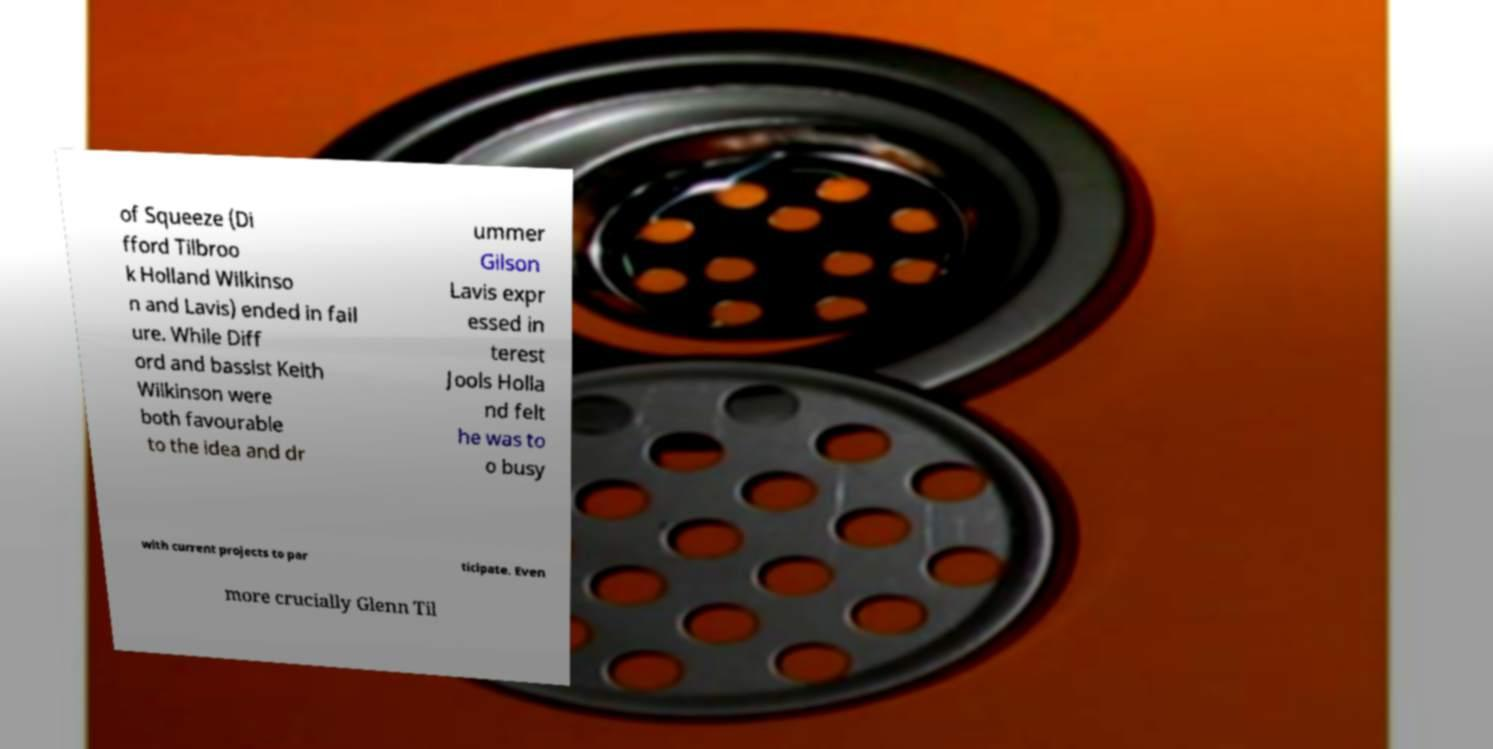Please identify and transcribe the text found in this image. of Squeeze (Di fford Tilbroo k Holland Wilkinso n and Lavis) ended in fail ure. While Diff ord and bassist Keith Wilkinson were both favourable to the idea and dr ummer Gilson Lavis expr essed in terest Jools Holla nd felt he was to o busy with current projects to par ticipate. Even more crucially Glenn Til 